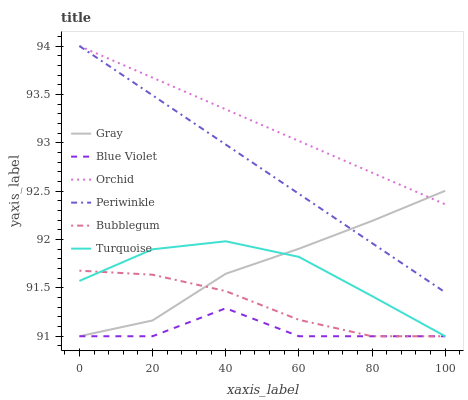Does Blue Violet have the minimum area under the curve?
Answer yes or no. Yes. Does Orchid have the maximum area under the curve?
Answer yes or no. Yes. Does Turquoise have the minimum area under the curve?
Answer yes or no. No. Does Turquoise have the maximum area under the curve?
Answer yes or no. No. Is Orchid the smoothest?
Answer yes or no. Yes. Is Blue Violet the roughest?
Answer yes or no. Yes. Is Turquoise the smoothest?
Answer yes or no. No. Is Turquoise the roughest?
Answer yes or no. No. Does Gray have the lowest value?
Answer yes or no. Yes. Does Periwinkle have the lowest value?
Answer yes or no. No. Does Orchid have the highest value?
Answer yes or no. Yes. Does Turquoise have the highest value?
Answer yes or no. No. Is Bubblegum less than Periwinkle?
Answer yes or no. Yes. Is Orchid greater than Bubblegum?
Answer yes or no. Yes. Does Gray intersect Periwinkle?
Answer yes or no. Yes. Is Gray less than Periwinkle?
Answer yes or no. No. Is Gray greater than Periwinkle?
Answer yes or no. No. Does Bubblegum intersect Periwinkle?
Answer yes or no. No. 